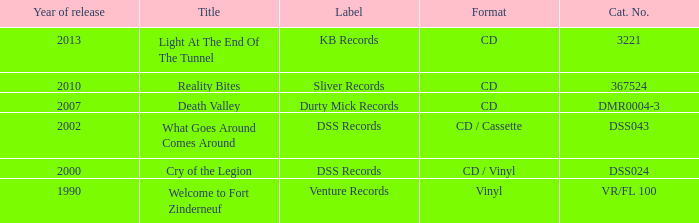What is the latest year of the album with the release title death valley? 2007.0. 